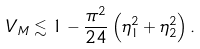Convert formula to latex. <formula><loc_0><loc_0><loc_500><loc_500>V _ { M } \lesssim 1 - \frac { \pi ^ { 2 } } { 2 4 } \left ( \eta _ { 1 } ^ { 2 } + \eta _ { 2 } ^ { 2 } \right ) .</formula> 